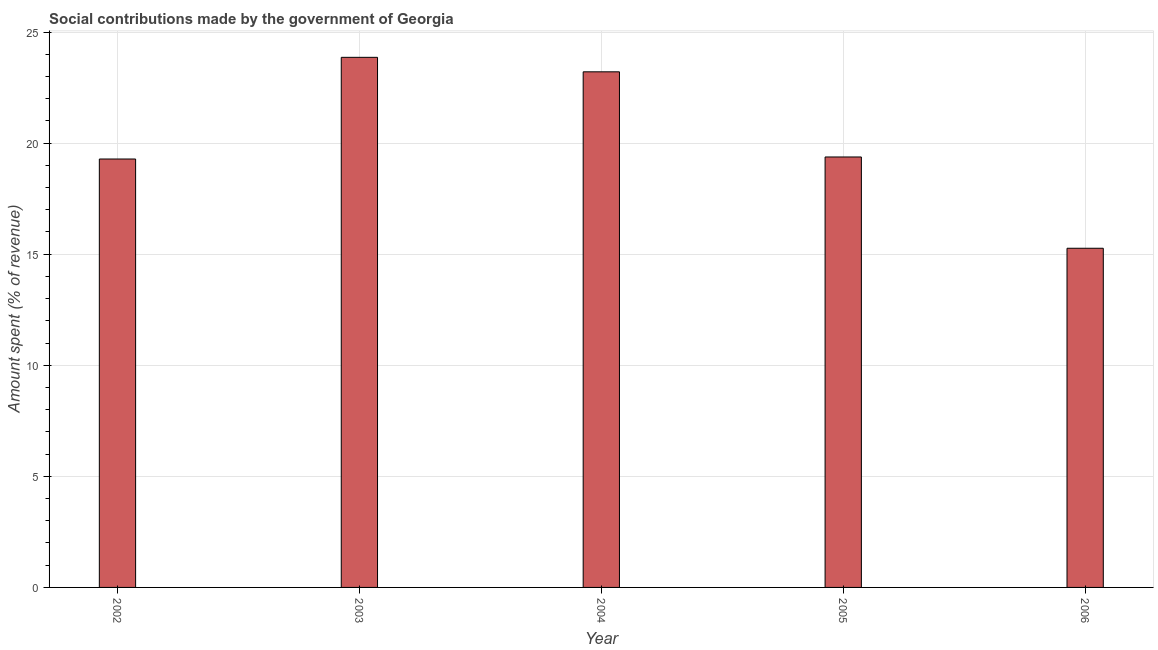Does the graph contain any zero values?
Keep it short and to the point. No. Does the graph contain grids?
Your response must be concise. Yes. What is the title of the graph?
Provide a succinct answer. Social contributions made by the government of Georgia. What is the label or title of the X-axis?
Provide a succinct answer. Year. What is the label or title of the Y-axis?
Your response must be concise. Amount spent (% of revenue). What is the amount spent in making social contributions in 2005?
Keep it short and to the point. 19.38. Across all years, what is the maximum amount spent in making social contributions?
Make the answer very short. 23.86. Across all years, what is the minimum amount spent in making social contributions?
Your answer should be very brief. 15.27. What is the sum of the amount spent in making social contributions?
Offer a terse response. 101. What is the difference between the amount spent in making social contributions in 2004 and 2006?
Ensure brevity in your answer.  7.94. What is the average amount spent in making social contributions per year?
Your answer should be compact. 20.2. What is the median amount spent in making social contributions?
Your answer should be very brief. 19.38. In how many years, is the amount spent in making social contributions greater than 5 %?
Make the answer very short. 5. What is the ratio of the amount spent in making social contributions in 2003 to that in 2006?
Keep it short and to the point. 1.56. Is the amount spent in making social contributions in 2005 less than that in 2006?
Your answer should be compact. No. Is the difference between the amount spent in making social contributions in 2004 and 2006 greater than the difference between any two years?
Make the answer very short. No. What is the difference between the highest and the second highest amount spent in making social contributions?
Offer a terse response. 0.65. Is the sum of the amount spent in making social contributions in 2003 and 2006 greater than the maximum amount spent in making social contributions across all years?
Offer a very short reply. Yes. What is the difference between the highest and the lowest amount spent in making social contributions?
Your answer should be very brief. 8.59. What is the difference between two consecutive major ticks on the Y-axis?
Offer a terse response. 5. What is the Amount spent (% of revenue) of 2002?
Make the answer very short. 19.28. What is the Amount spent (% of revenue) in 2003?
Your answer should be very brief. 23.86. What is the Amount spent (% of revenue) in 2004?
Provide a succinct answer. 23.21. What is the Amount spent (% of revenue) in 2005?
Your response must be concise. 19.38. What is the Amount spent (% of revenue) of 2006?
Your answer should be very brief. 15.27. What is the difference between the Amount spent (% of revenue) in 2002 and 2003?
Provide a short and direct response. -4.58. What is the difference between the Amount spent (% of revenue) in 2002 and 2004?
Make the answer very short. -3.92. What is the difference between the Amount spent (% of revenue) in 2002 and 2005?
Provide a short and direct response. -0.09. What is the difference between the Amount spent (% of revenue) in 2002 and 2006?
Offer a very short reply. 4.02. What is the difference between the Amount spent (% of revenue) in 2003 and 2004?
Keep it short and to the point. 0.65. What is the difference between the Amount spent (% of revenue) in 2003 and 2005?
Your answer should be compact. 4.49. What is the difference between the Amount spent (% of revenue) in 2003 and 2006?
Provide a short and direct response. 8.59. What is the difference between the Amount spent (% of revenue) in 2004 and 2005?
Offer a terse response. 3.83. What is the difference between the Amount spent (% of revenue) in 2004 and 2006?
Give a very brief answer. 7.94. What is the difference between the Amount spent (% of revenue) in 2005 and 2006?
Your response must be concise. 4.11. What is the ratio of the Amount spent (% of revenue) in 2002 to that in 2003?
Provide a short and direct response. 0.81. What is the ratio of the Amount spent (% of revenue) in 2002 to that in 2004?
Offer a terse response. 0.83. What is the ratio of the Amount spent (% of revenue) in 2002 to that in 2005?
Ensure brevity in your answer.  0.99. What is the ratio of the Amount spent (% of revenue) in 2002 to that in 2006?
Ensure brevity in your answer.  1.26. What is the ratio of the Amount spent (% of revenue) in 2003 to that in 2004?
Give a very brief answer. 1.03. What is the ratio of the Amount spent (% of revenue) in 2003 to that in 2005?
Make the answer very short. 1.23. What is the ratio of the Amount spent (% of revenue) in 2003 to that in 2006?
Keep it short and to the point. 1.56. What is the ratio of the Amount spent (% of revenue) in 2004 to that in 2005?
Offer a very short reply. 1.2. What is the ratio of the Amount spent (% of revenue) in 2004 to that in 2006?
Offer a terse response. 1.52. What is the ratio of the Amount spent (% of revenue) in 2005 to that in 2006?
Keep it short and to the point. 1.27. 